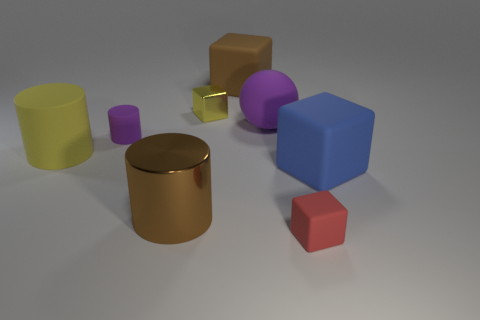Add 2 red matte cubes. How many objects exist? 10 Subtract all cylinders. How many objects are left? 5 Subtract all big red rubber blocks. Subtract all small rubber cylinders. How many objects are left? 7 Add 3 yellow blocks. How many yellow blocks are left? 4 Add 7 yellow rubber objects. How many yellow rubber objects exist? 8 Subtract 0 green blocks. How many objects are left? 8 